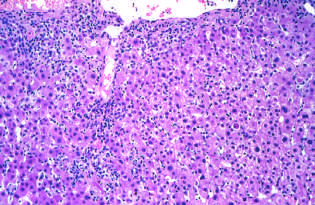s the entire thickness of the epithelium characterize by a predominantly lymphocytic infiltrate?
Answer the question using a single word or phrase. No 